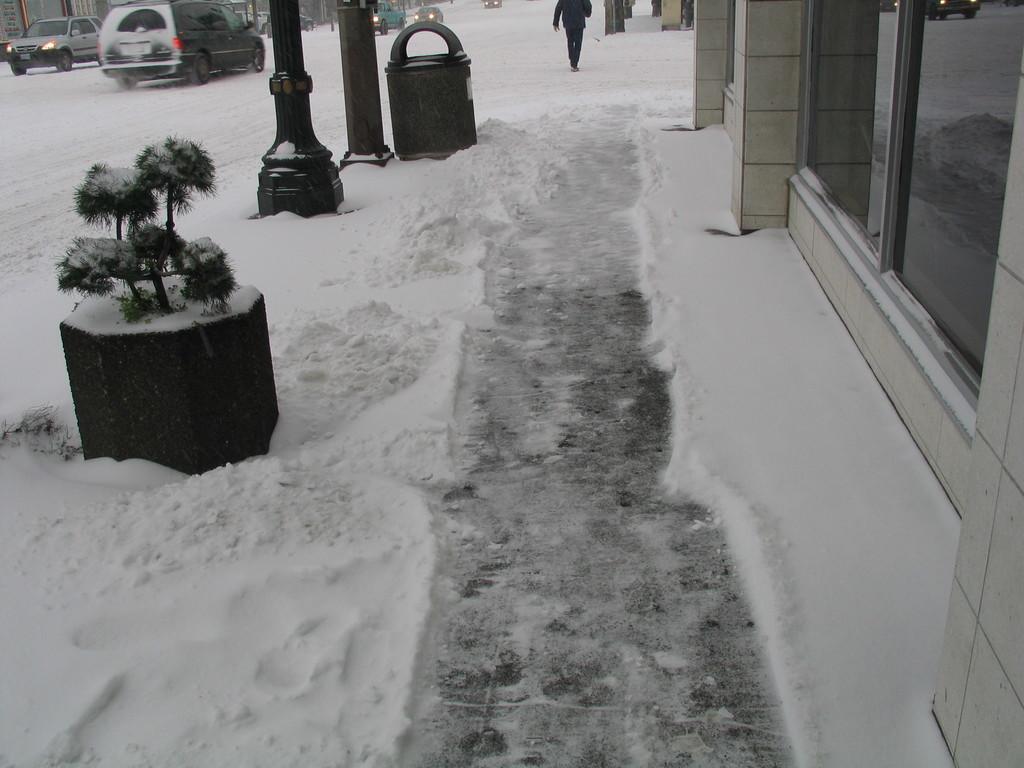Can you describe this image briefly? In this image we can see land full of snow. Right side of the image one wall with glass window is there. Left side of the image cars are moving and pillars are there. And one plant and dustbin is present. 